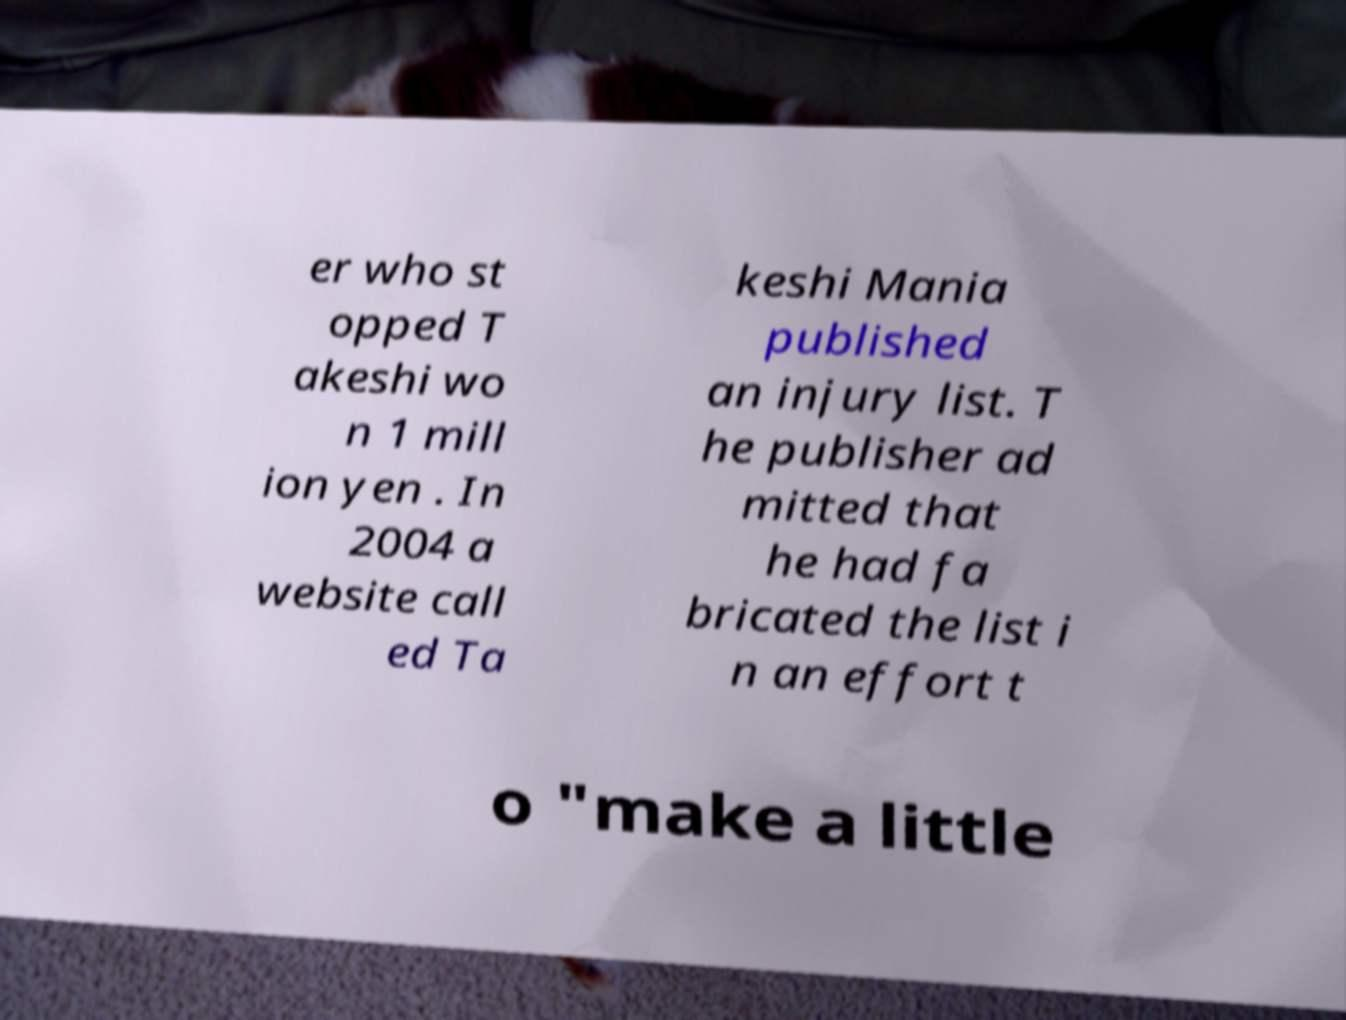There's text embedded in this image that I need extracted. Can you transcribe it verbatim? er who st opped T akeshi wo n 1 mill ion yen . In 2004 a website call ed Ta keshi Mania published an injury list. T he publisher ad mitted that he had fa bricated the list i n an effort t o "make a little 